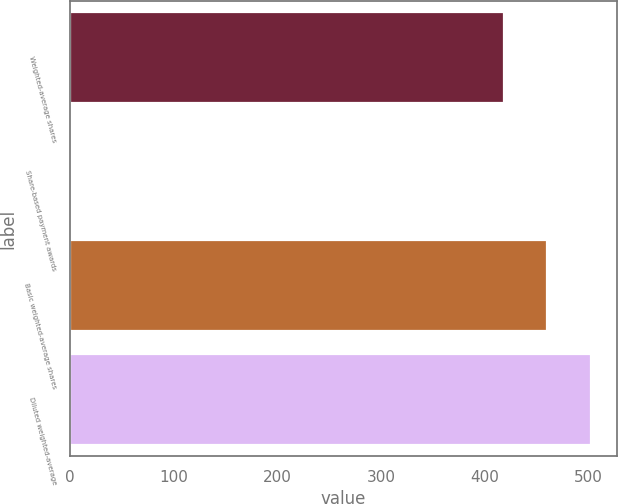Convert chart. <chart><loc_0><loc_0><loc_500><loc_500><bar_chart><fcel>Weighted-average shares<fcel>Share-based payment awards<fcel>Basic weighted-average shares<fcel>Diluted weighted-average<nl><fcel>418.3<fcel>1.5<fcel>460.28<fcel>502.26<nl></chart> 